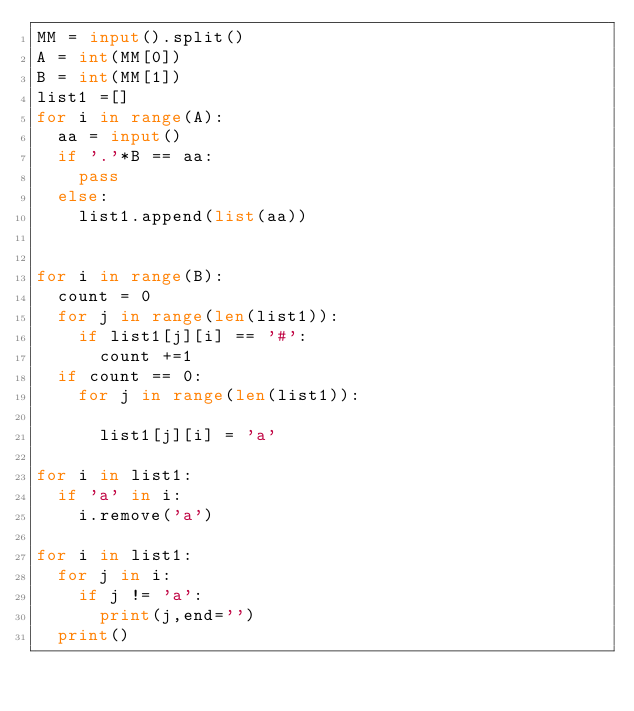<code> <loc_0><loc_0><loc_500><loc_500><_Python_>MM = input().split()
A = int(MM[0])
B = int(MM[1])
list1 =[]
for i in range(A):
  aa = input()
  if '.'*B == aa:
    pass
  else:
    list1.append(list(aa))


for i in range(B):
  count = 0
  for j in range(len(list1)):
    if list1[j][i] == '#':
      count +=1
  if count == 0:
    for j in range(len(list1)):
     
      list1[j][i] = 'a'

for i in list1:
  if 'a' in i:
    i.remove('a')

for i in list1:
  for j in i:
    if j != 'a':
      print(j,end='')
  print()
    
  
               
    
  
               </code> 